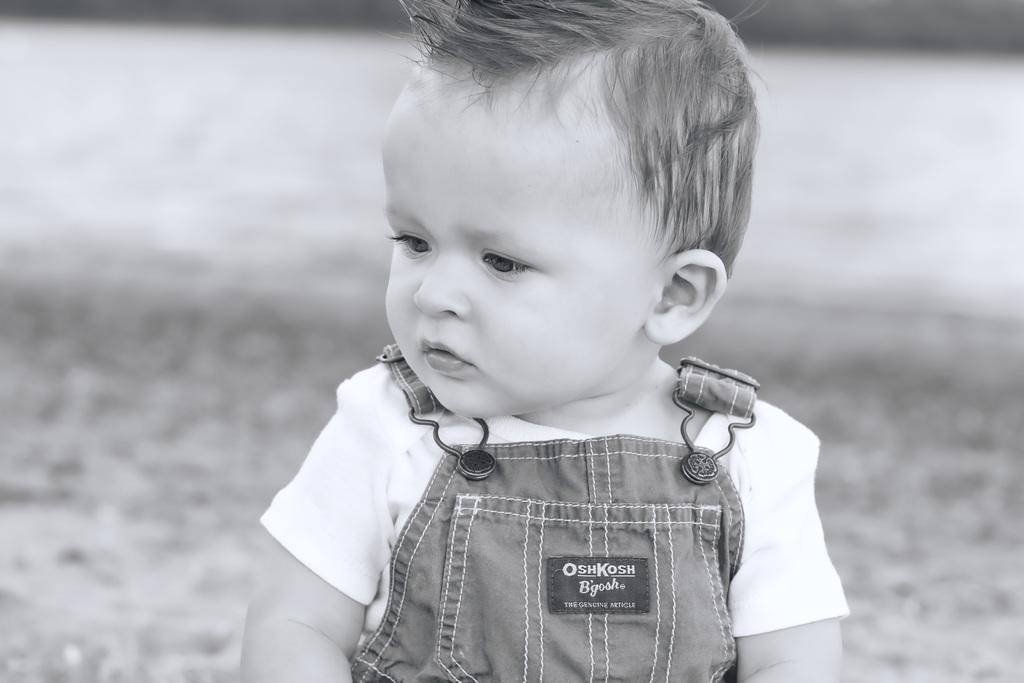What is the color scheme of the image? The image is black and white. What can be seen in the image? There is a child in the image. Can you see any snakes in the image? There are no snakes present in the image. What message of hope does the image convey? The image does not convey any specific message of hope, as it only features a child in a black and white setting. 